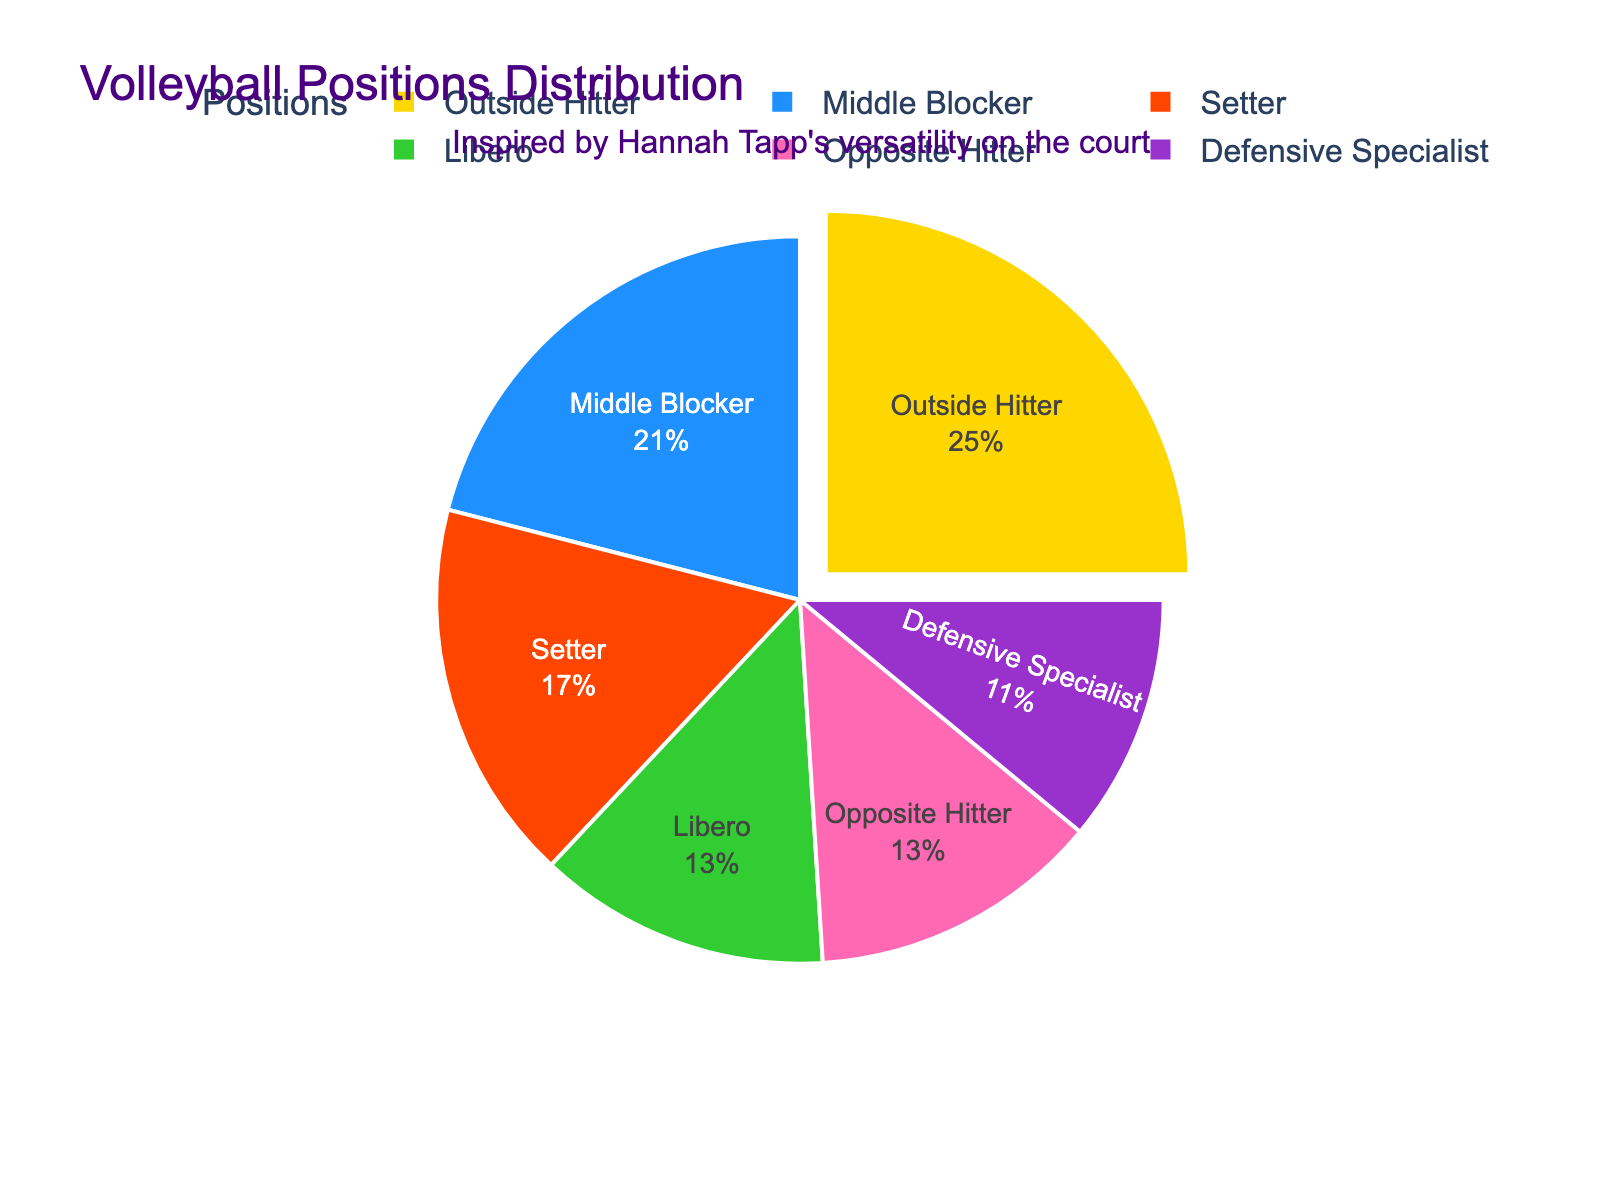What is the largest percentage representation among the positions? The segment with the largest percentage representation can be seen visually as the biggest slice of the pie chart labeled "Outside Hitter". The percentage associated with this label is 25%.
Answer: 25% What is the combined percentage of Middle Blocker and Setter positions? The slices labeled "Middle Blocker" and "Setter" have percentages of 21% and 17% respectively. Adding these two percentages together gives us 21 + 17 = 38%.
Answer: 38% Which positions have an equal percentage representation? The pie chart shows that both the "Libero" and the "Opposite Hitter" positions are represented by the same sized slices, each labeled with 13%.
Answer: Libero and Opposite Hitter What is the total percentage representation of the defensive roles (Libero and Defensive Specialist)? The pie chart labels "Libero" with 13% and "Defensive Specialist" with 11%. Adding these percentages together gives 13 + 11 = 24%.
Answer: 24% Which position is closest in percentage to the Setter, but not the same? The Setter position has a percentage of 17%. The closest percentage to this without being the same is "Libero" and "Opposite Hitter" both with 13%.
Answer: Libero and Opposite Hitter Is the combined representation of Defensive Specialist and Outside Hitter greater than 30%? The slices labeled "Defensive Specialist" and "Outside Hitter" have percentages of 11% and 25% respectively. Adding these together gives 11 + 25 = 36%, which is greater than 30%.
Answer: Yes How much larger is the Middle Blocker's percentage compared to the Defensive Specialist's? The pie chart labels "Middle Blocker" with 21% and "Defensive Specialist" with 11%. Subtracting these values gives 21 - 11 = 10%.
Answer: 10% What color is used to represent the Setter position? The pie chart uses distinct colors for each position and the slice labeled "Setter" is represented in blue.
Answer: Blue What is the average percentage representation of all positions? Summing up all percentages: 25% (Outside Hitter) + 21% (Middle Blocker) + 17% (Setter) + 13% (Libero) + 13% (Opposite Hitter) + 11% (Defensive Specialist) = 100%. Dividing by the number of positions (6) gives 100 / 6 ≈ 16.67%.
Answer: 16.67% Is the total percentage representation of attacking positions (Outside Hitter and Opposite Hitter) greater than the combined representation of Middle Blocker and Setter? Summing the percentages for attacking positions: 25% (Outside Hitter) + 13% (Opposite Hitter) = 38%. Summing for Middle Blocker and Setter: 21% + 17% = 38%. Both sums are equal.
Answer: No (It's equal) 